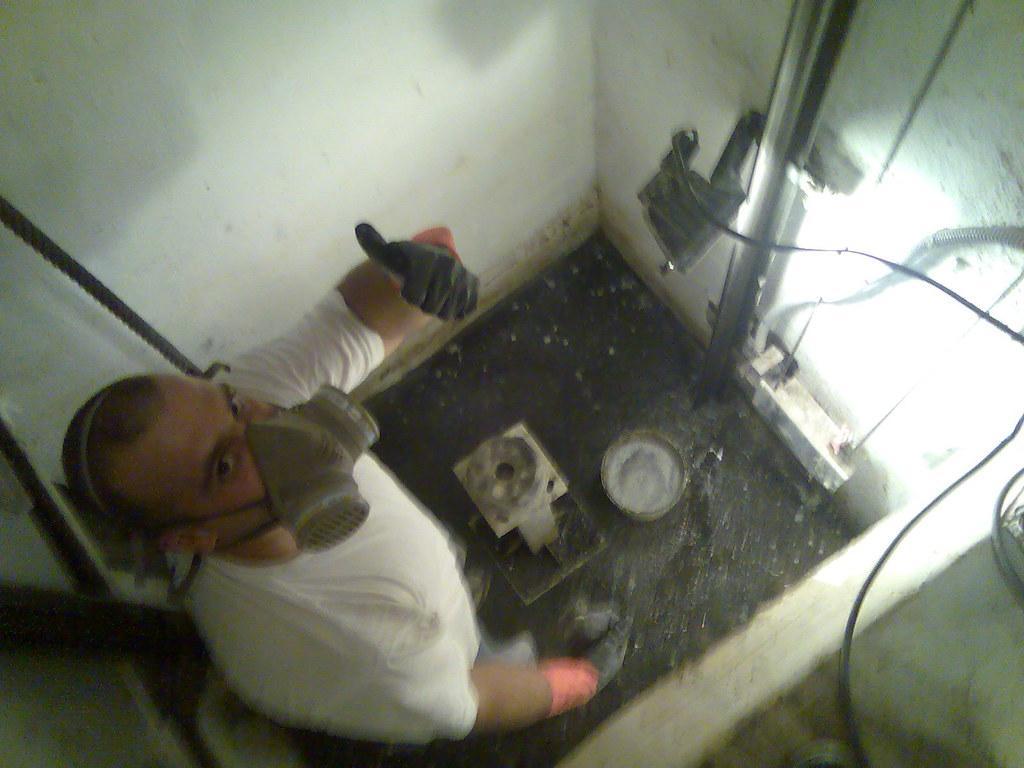Describe this image in one or two sentences. In this image I can see person is wearing mask and white shirt. He is standing. In front I can see a bucket,metal rod and wires. The wall is in white color. 